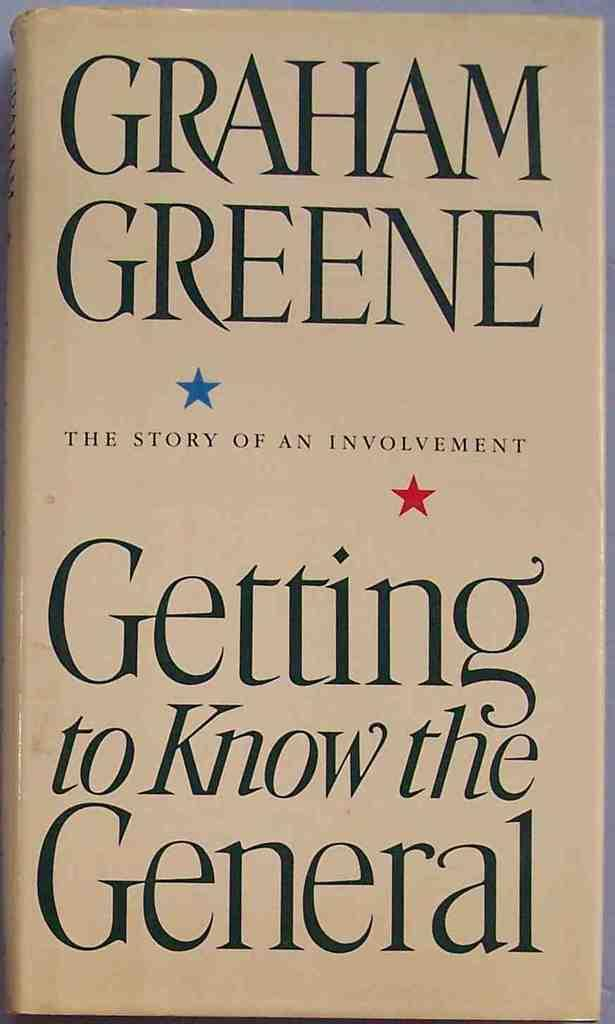<image>
Render a clear and concise summary of the photo. Graham Greene has written a book titles Getting to Know the General; The Story of an Involvement is shown alone. 